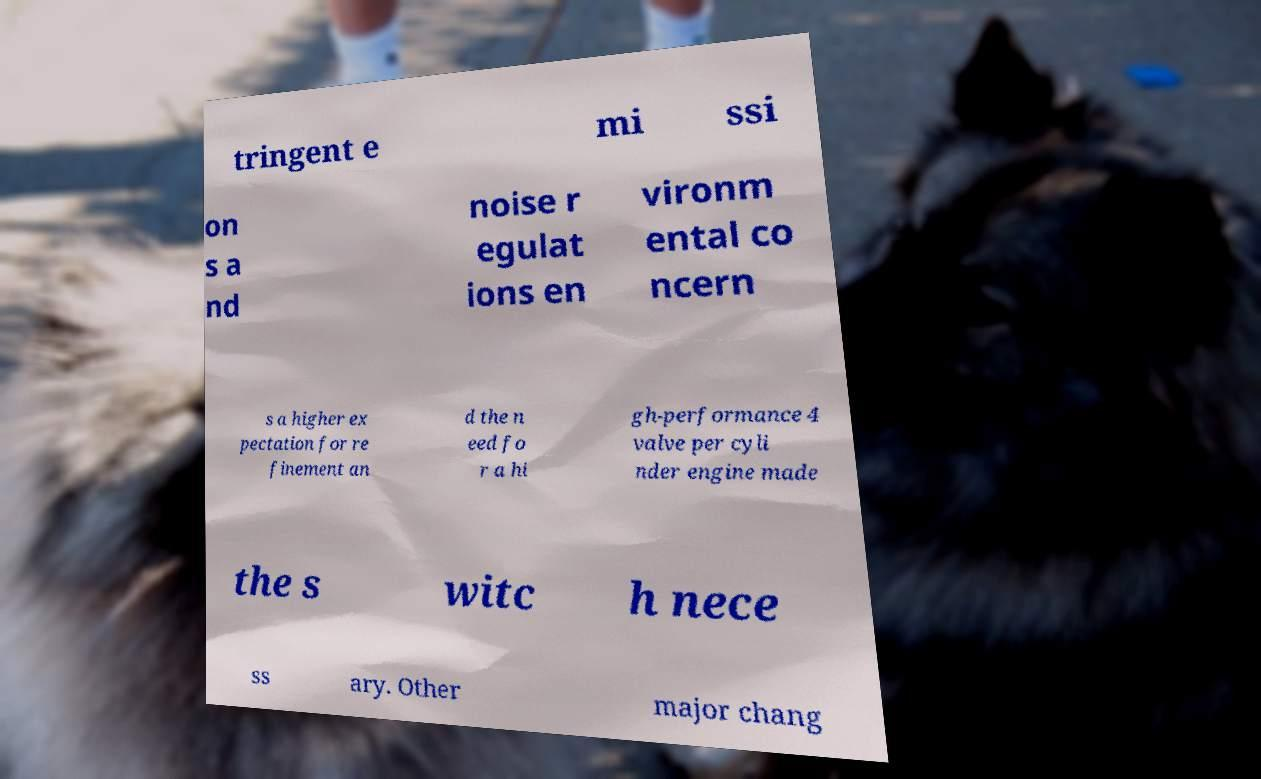I need the written content from this picture converted into text. Can you do that? tringent e mi ssi on s a nd noise r egulat ions en vironm ental co ncern s a higher ex pectation for re finement an d the n eed fo r a hi gh-performance 4 valve per cyli nder engine made the s witc h nece ss ary. Other major chang 